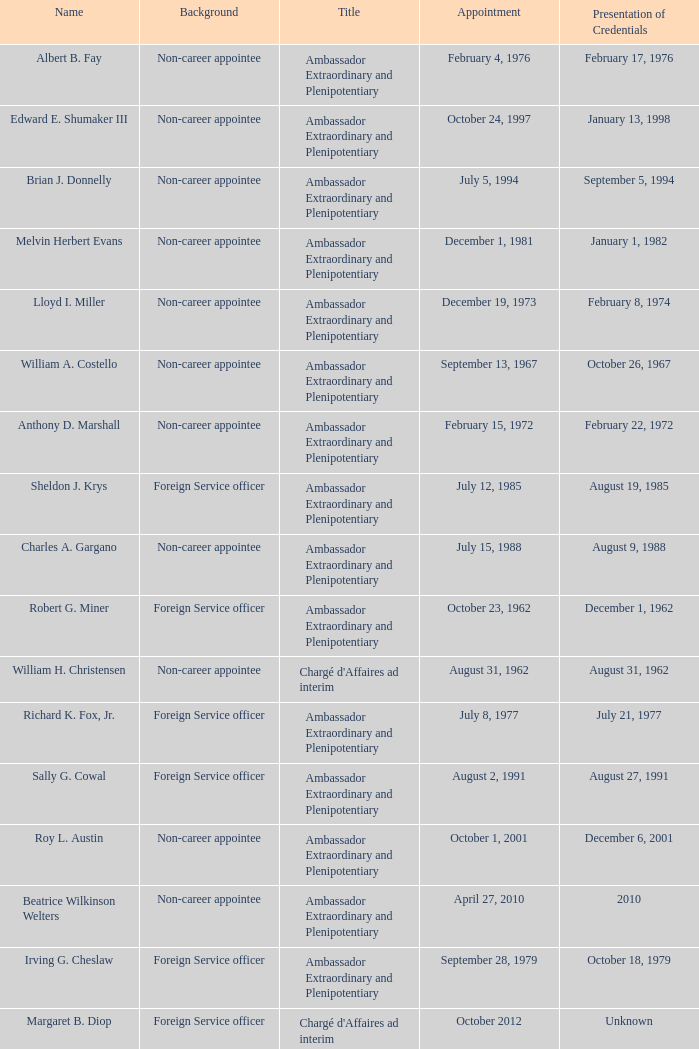When did Robert G. Miner present his credentials? December 1, 1962. 